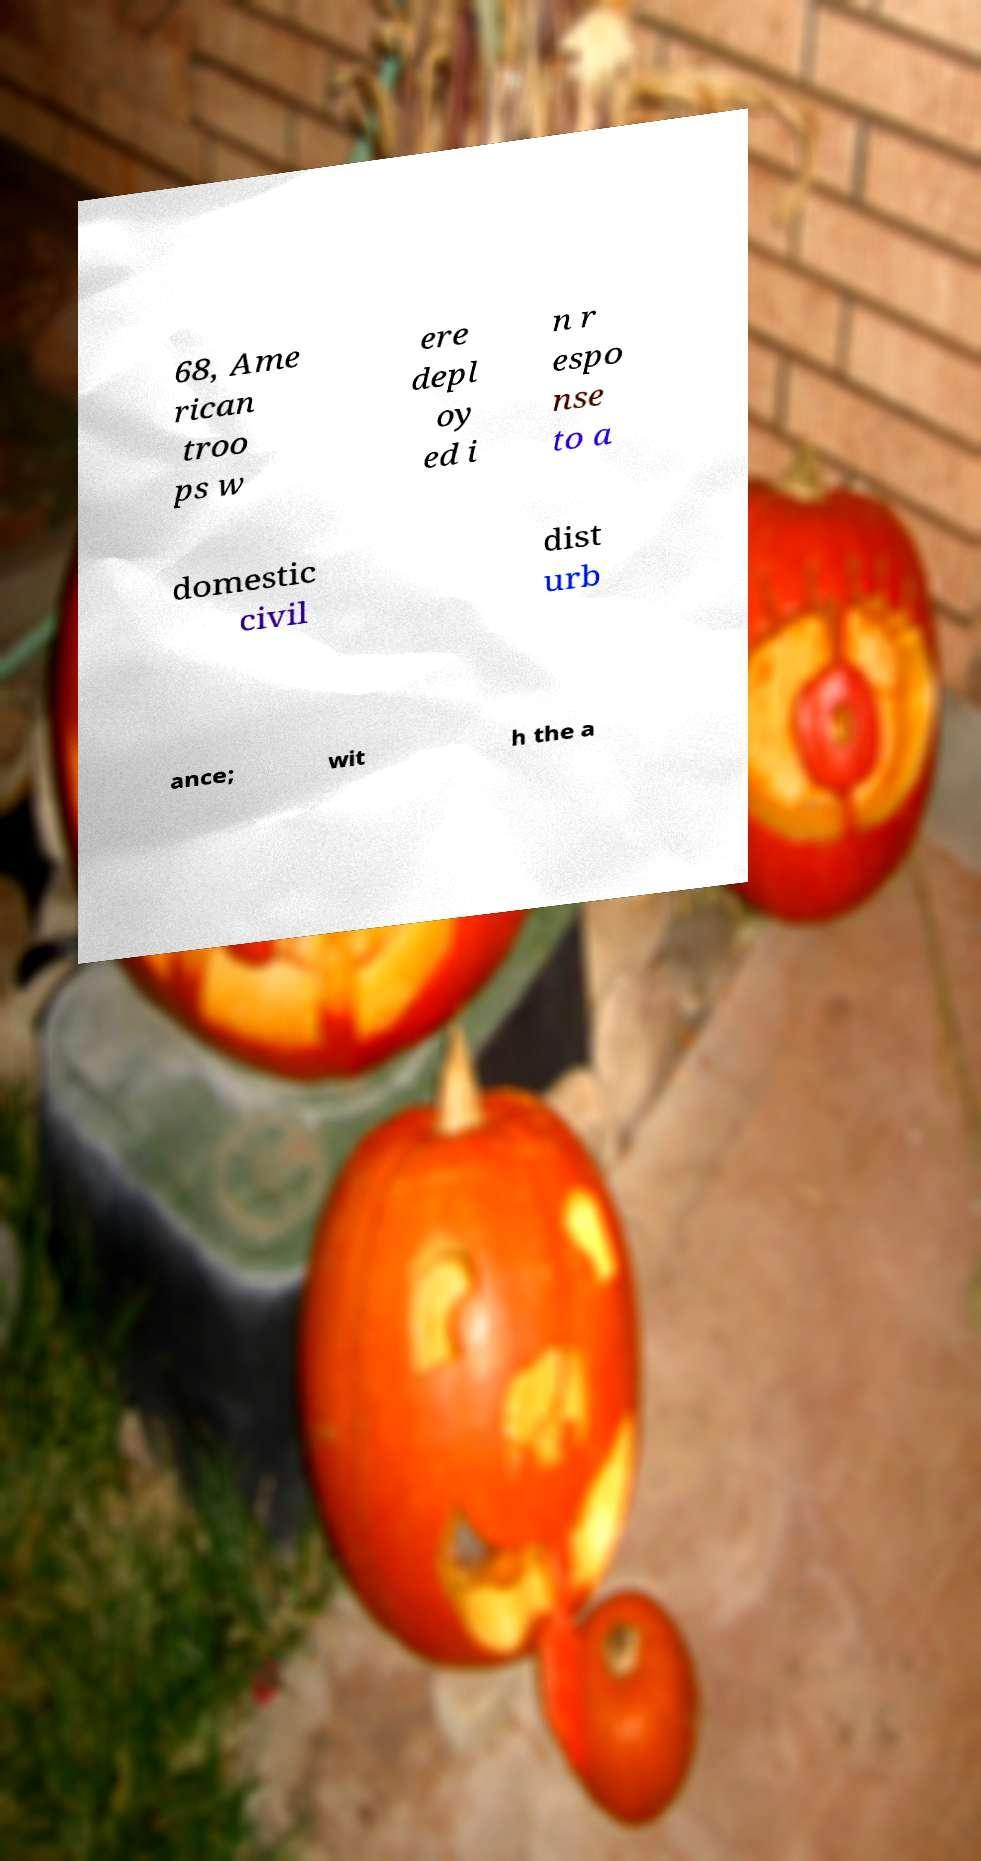Can you accurately transcribe the text from the provided image for me? 68, Ame rican troo ps w ere depl oy ed i n r espo nse to a domestic civil dist urb ance; wit h the a 